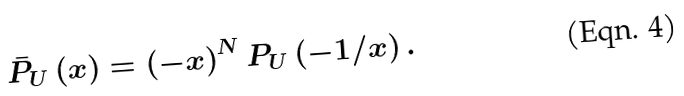Convert formula to latex. <formula><loc_0><loc_0><loc_500><loc_500>\bar { P } _ { U } \left ( x \right ) = \left ( - x \right ) ^ { N } P _ { U } \left ( - 1 / x \right ) .</formula> 